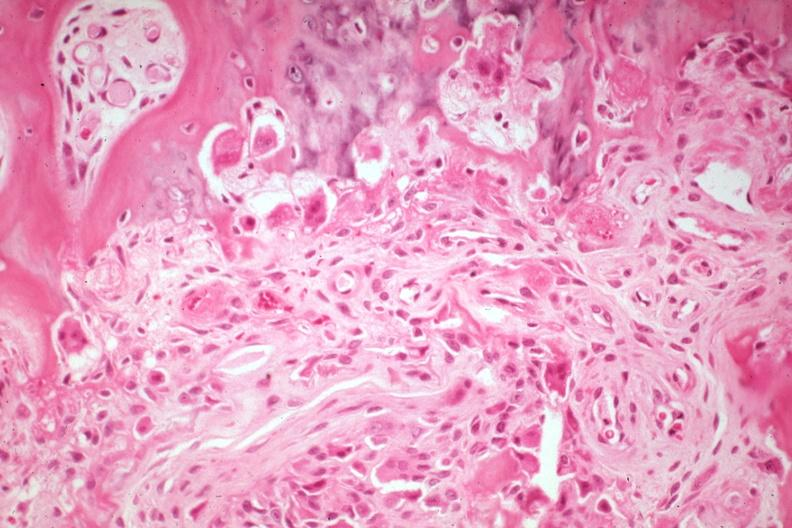what does this image show?
Answer the question using a single word or phrase. High new bone formation with osteoblasts and osteoclasts and some remaining cartilage an excellent example from a non-union 